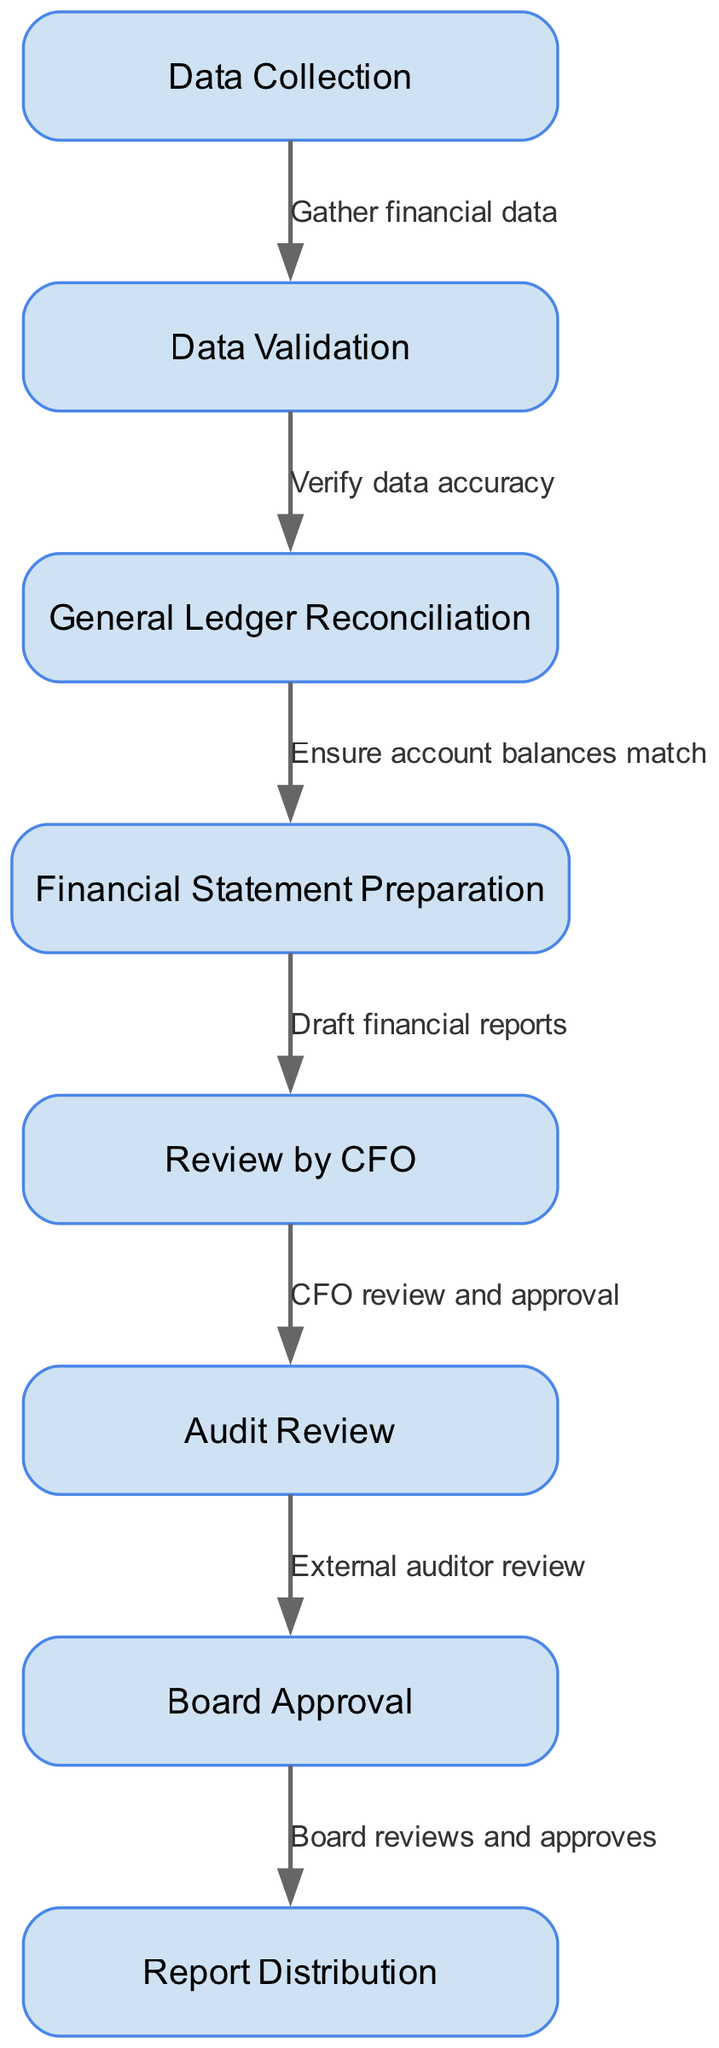What is the first step in the financial reporting process? The first step in the diagram is labeled "Data Collection," indicating that this is where financial data is initially gathered.
Answer: Data Collection How many nodes are there in the diagram? By counting the number of distinct elements listed in the "nodes" section, we find there are eight nodes in total, corresponding to various steps in the financial reporting process.
Answer: 8 What node follows "Data Validation"? The flow from "Data Validation" leads to "General Ledger Reconciliation" as the next sequential step according to the diagram's edges.
Answer: General Ledger Reconciliation What is the final step in the financial reporting process? The last node in the sequence is "Report Distribution," which indicates this is the final step where reports are shared.
Answer: Report Distribution How many edges are in the diagram? The number of edges can be counted from the "edges" section in the data, totaling seven edges that connect various nodes in the financial reporting process.
Answer: 7 Which step requires external auditor review? The node labeled "Audit Review" indicates it is the step where an external auditor reviews the financial statements prior to board approval.
Answer: Audit Review What is the relationship between "Review by CFO" and "Audit Review"? The diagram shows that "Audit Review" follows "Review by CFO," signifying that the CFO's approval must occur before the audit is conducted.
Answer: CFO review and approval What step must happen after "Board Approval"? The follow-up step after "Board Approval" is "Report Distribution," indicating that once the board approves, the reports can be shared with relevant parties.
Answer: Report Distribution What is the second step in the process? The diagram indicates that after "Data Collection," the second step is "Data Validation," where the accuracy of the collected data is verified.
Answer: Data Validation 